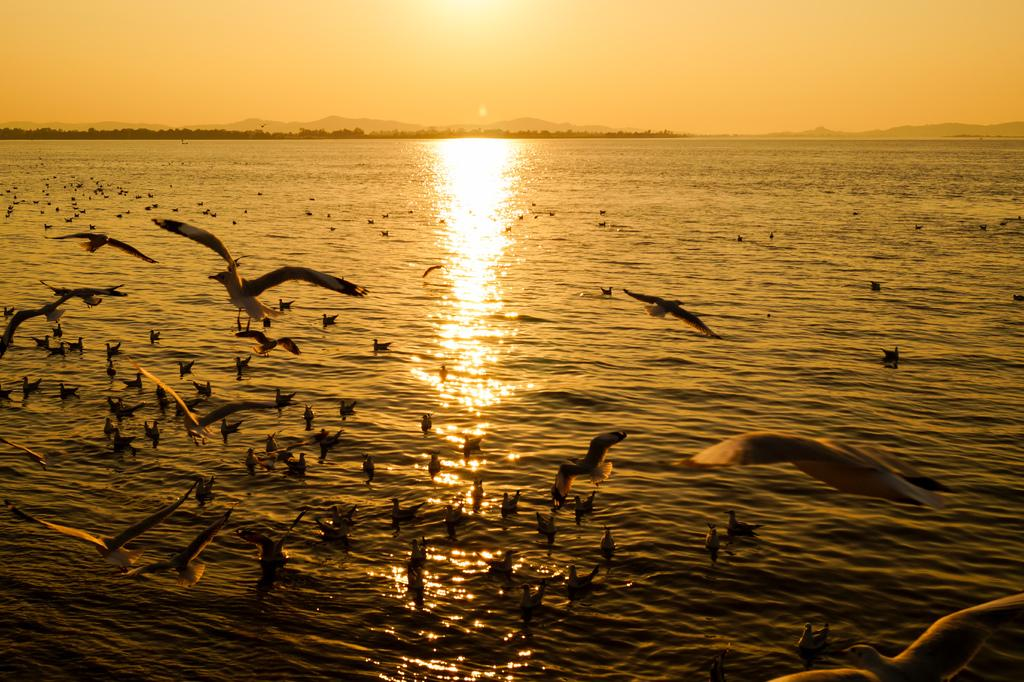What type of animals can be seen in the image? Birds can be seen in the image. What is the primary element in which the birds are situated? The birds are situated in water. What type of natural landscape is visible in the image? There are mountains and trees visible in the image. What is visible in the sky in the image? The sky is visible in the image, and the sun is observable. What type of building can be seen in the image? There is no building present in the image; it features birds in water with a mountainous and forested background. Is there a railway visible in the image? There is no railway present in the image. 